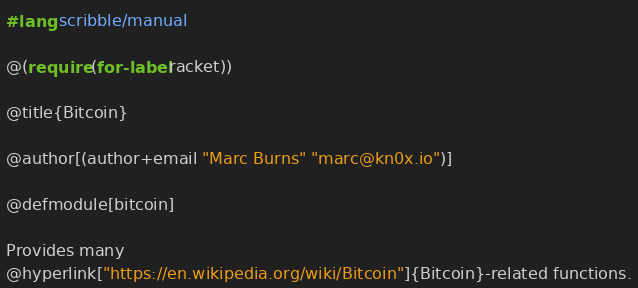<code> <loc_0><loc_0><loc_500><loc_500><_Racket_>#lang scribble/manual

@(require (for-label racket))

@title{Bitcoin}

@author[(author+email "Marc Burns" "marc@kn0x.io")]

@defmodule[bitcoin]

Provides many
@hyperlink["https://en.wikipedia.org/wiki/Bitcoin"]{Bitcoin}-related functions.
</code> 